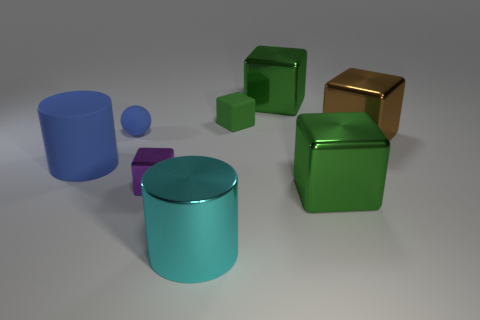Subtract all purple cylinders. How many green cubes are left? 3 Subtract all brown cubes. How many cubes are left? 4 Subtract 2 cubes. How many cubes are left? 3 Subtract all purple blocks. How many blocks are left? 4 Subtract all cyan cubes. Subtract all blue spheres. How many cubes are left? 5 Add 1 tiny blue rubber things. How many objects exist? 9 Subtract all blocks. How many objects are left? 3 Add 7 purple things. How many purple things exist? 8 Subtract 0 gray blocks. How many objects are left? 8 Subtract all brown metallic cylinders. Subtract all small purple blocks. How many objects are left? 7 